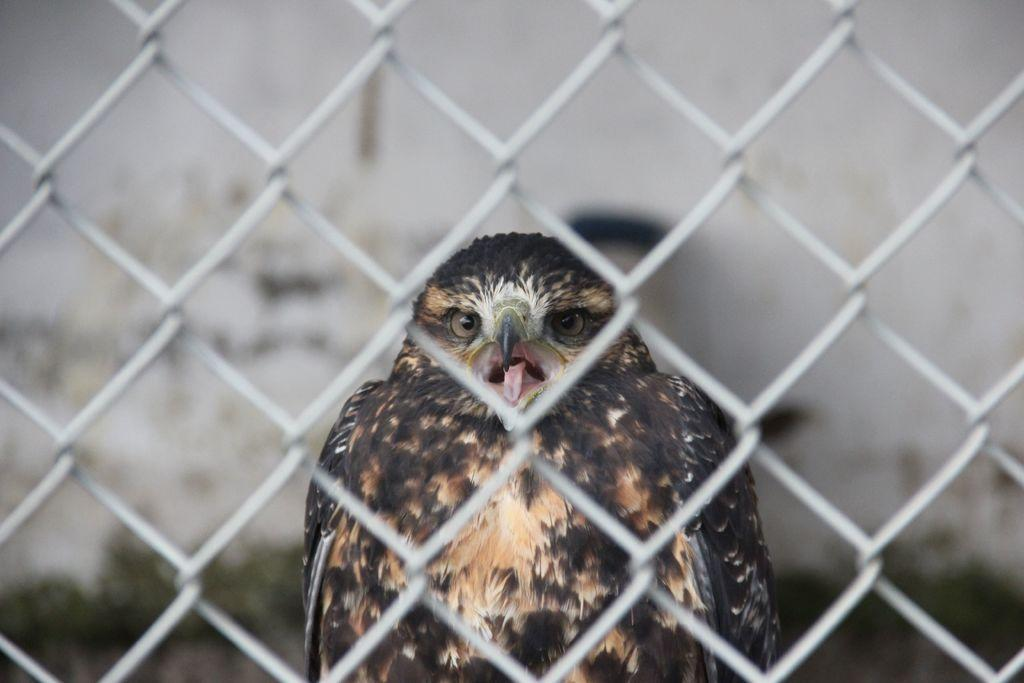What is located in the foreground of the image? There is a net in the foreground of the image. What can be seen behind the net? There is a bird visible behind the net. What is in the background of the image? There is a wall in the background of the image. What type of jelly can be seen on the wall in the image? There is no jelly present on the wall in the image. Can you tell me how many giraffes are visible behind the net? There are no giraffes visible in the image; only a bird is present behind the net. 